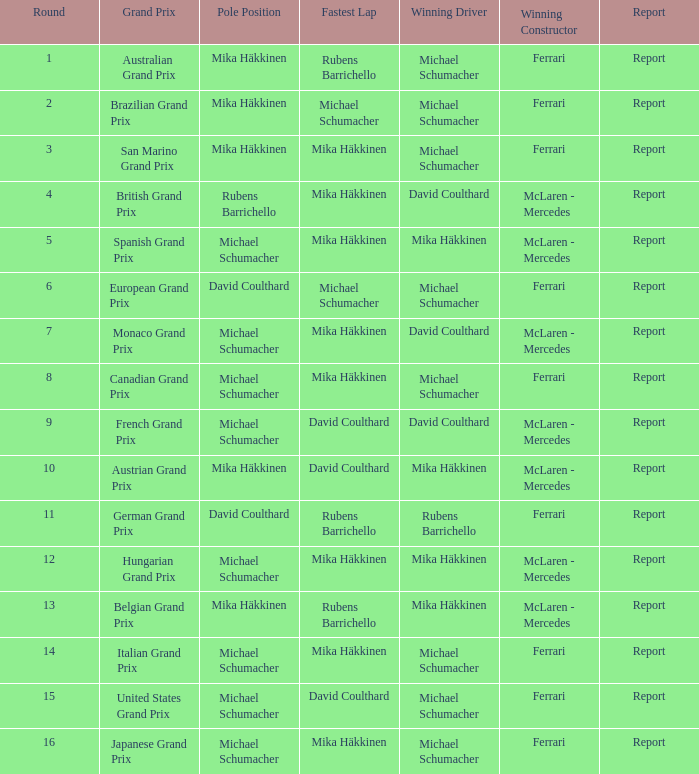Which round had Michael Schumacher in the pole position, David Coulthard with the fastest lap, and McLaren - Mercedes as the winning constructor? 1.0. 